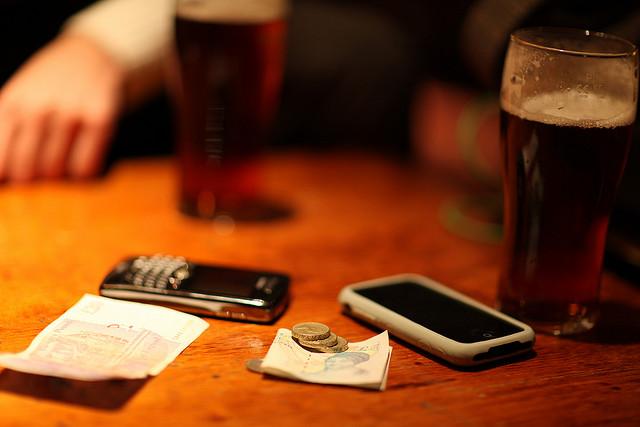What body part can be seen in the background?
Answer briefly. Hand. What beverage is in the glasses?
Keep it brief. Beer. What kind of money is on the table?
Quick response, please. Canadian. 